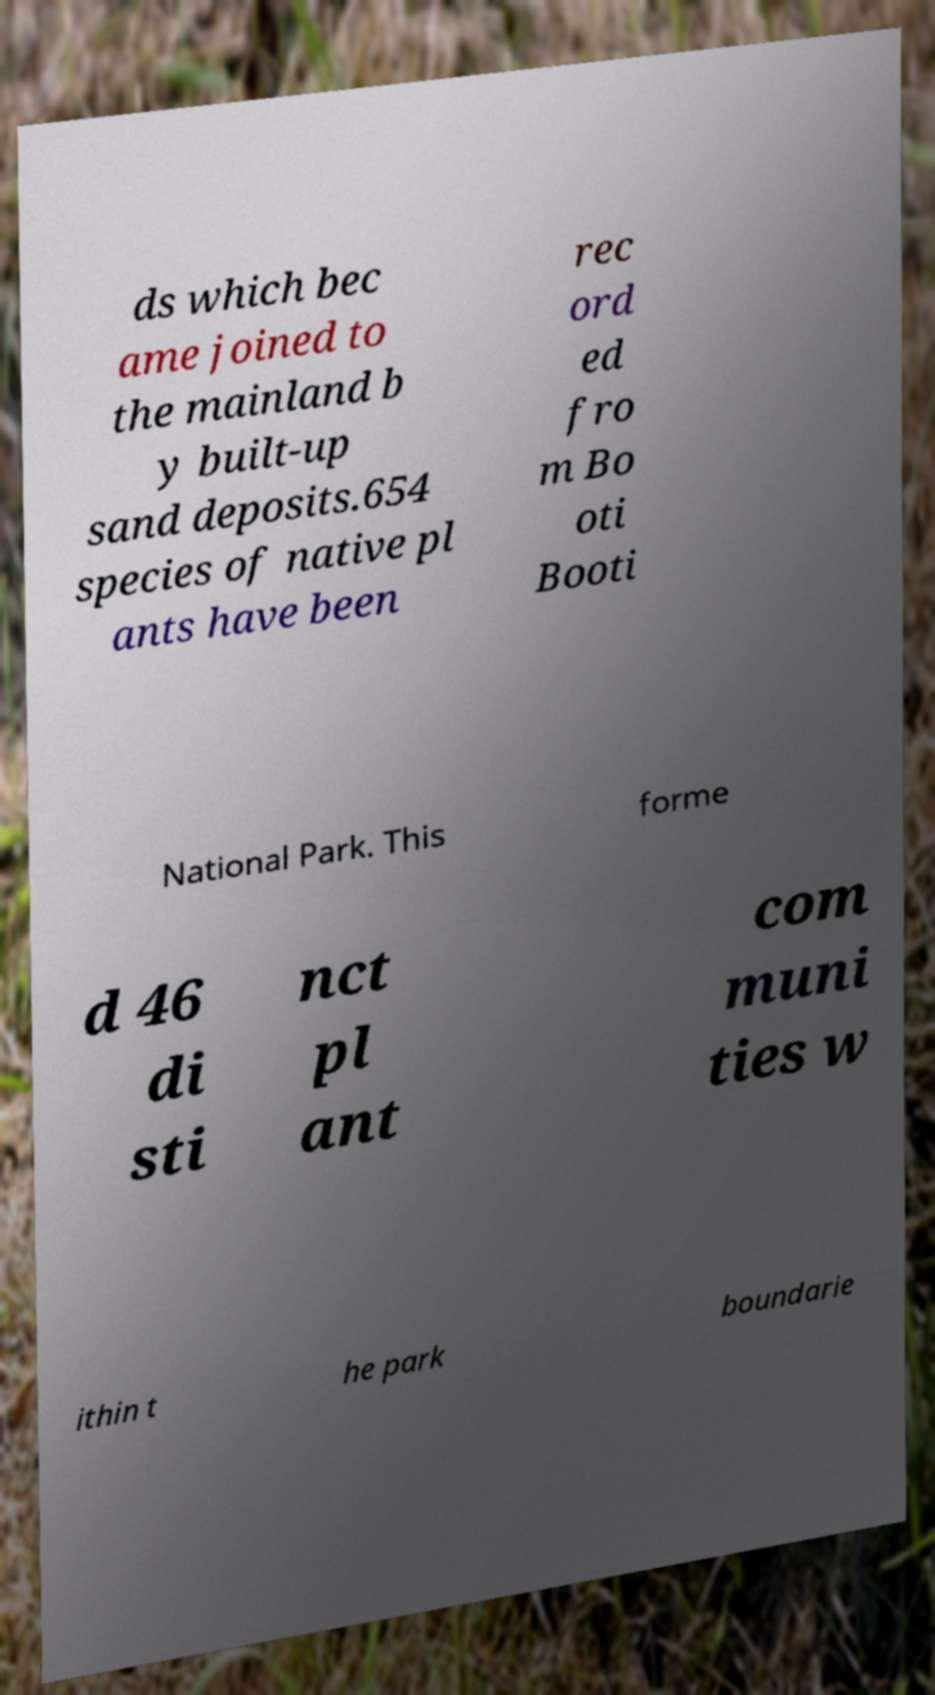Please read and relay the text visible in this image. What does it say? ds which bec ame joined to the mainland b y built-up sand deposits.654 species of native pl ants have been rec ord ed fro m Bo oti Booti National Park. This forme d 46 di sti nct pl ant com muni ties w ithin t he park boundarie 